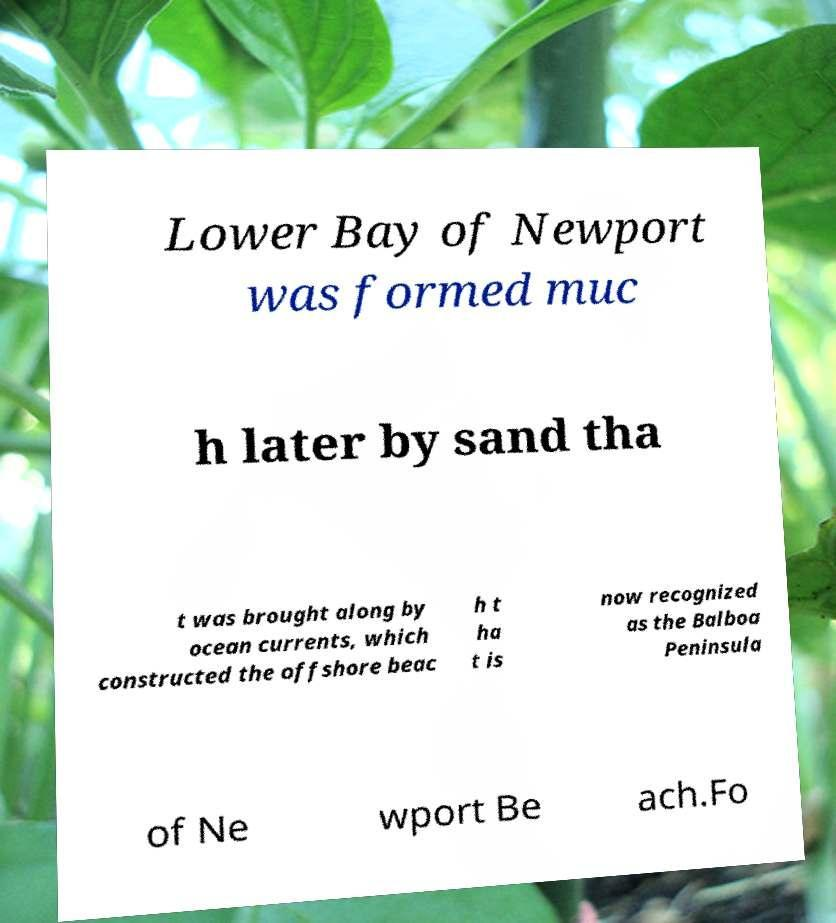There's text embedded in this image that I need extracted. Can you transcribe it verbatim? Lower Bay of Newport was formed muc h later by sand tha t was brought along by ocean currents, which constructed the offshore beac h t ha t is now recognized as the Balboa Peninsula of Ne wport Be ach.Fo 